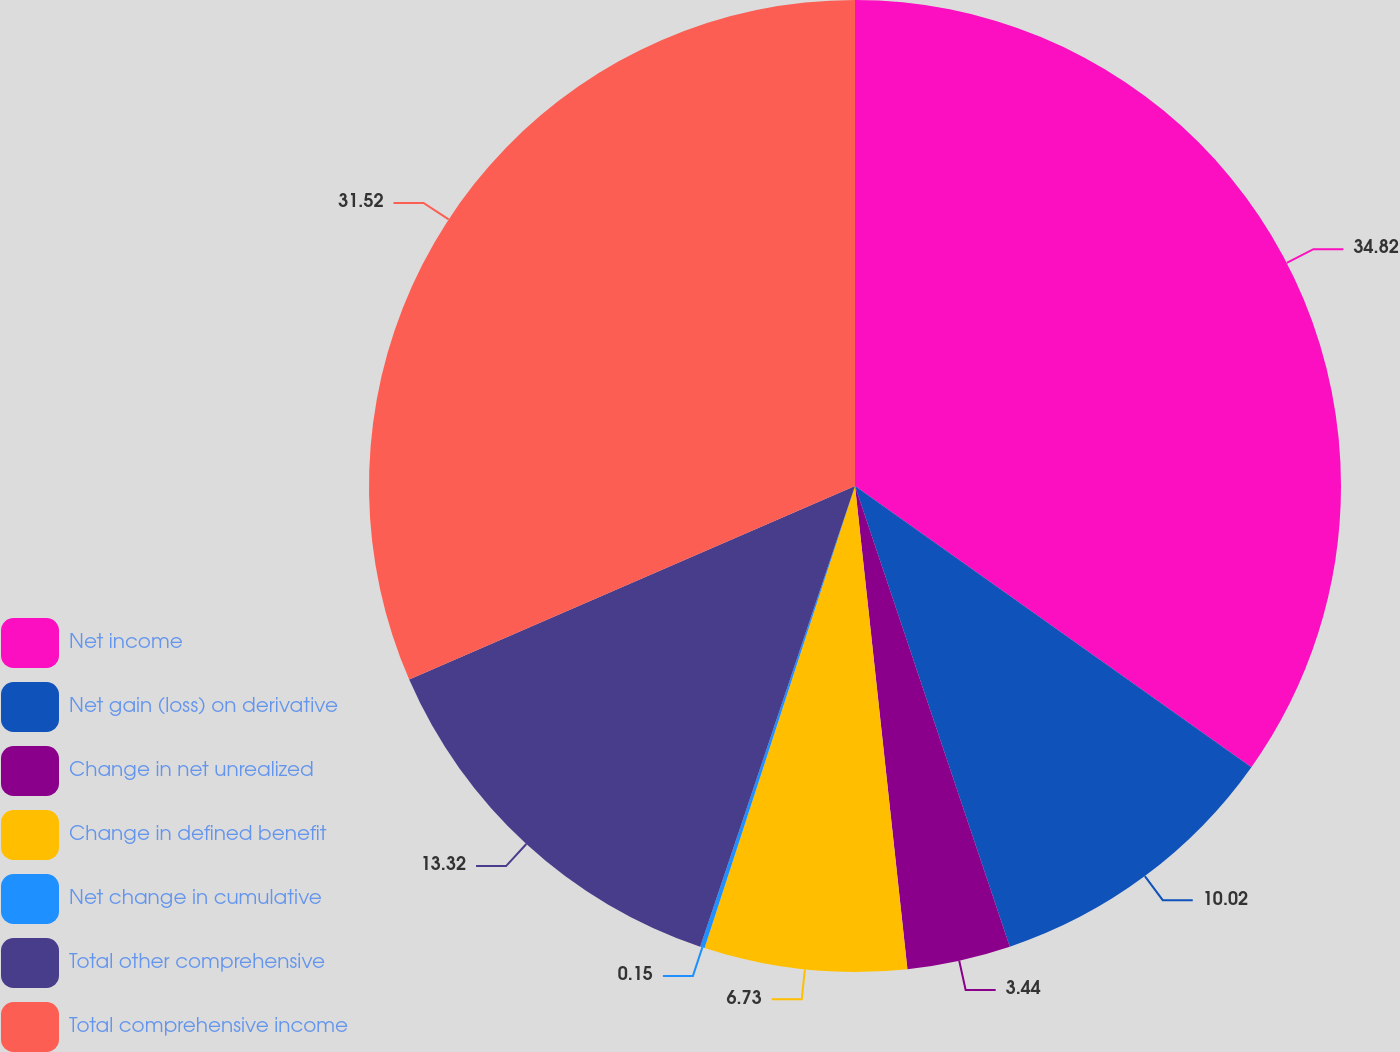Convert chart to OTSL. <chart><loc_0><loc_0><loc_500><loc_500><pie_chart><fcel>Net income<fcel>Net gain (loss) on derivative<fcel>Change in net unrealized<fcel>Change in defined benefit<fcel>Net change in cumulative<fcel>Total other comprehensive<fcel>Total comprehensive income<nl><fcel>34.82%<fcel>10.02%<fcel>3.44%<fcel>6.73%<fcel>0.15%<fcel>13.32%<fcel>31.52%<nl></chart> 